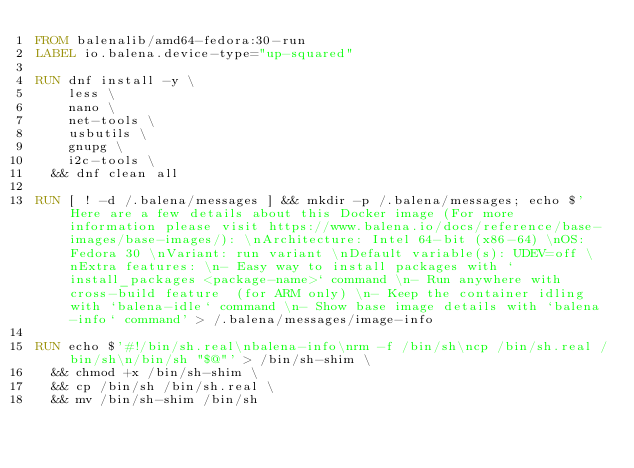<code> <loc_0><loc_0><loc_500><loc_500><_Dockerfile_>FROM balenalib/amd64-fedora:30-run
LABEL io.balena.device-type="up-squared"

RUN dnf install -y \
		less \
		nano \
		net-tools \
		usbutils \
		gnupg \
		i2c-tools \
	&& dnf clean all

RUN [ ! -d /.balena/messages ] && mkdir -p /.balena/messages; echo $'Here are a few details about this Docker image (For more information please visit https://www.balena.io/docs/reference/base-images/base-images/): \nArchitecture: Intel 64-bit (x86-64) \nOS: Fedora 30 \nVariant: run variant \nDefault variable(s): UDEV=off \nExtra features: \n- Easy way to install packages with `install_packages <package-name>` command \n- Run anywhere with cross-build feature  (for ARM only) \n- Keep the container idling with `balena-idle` command \n- Show base image details with `balena-info` command' > /.balena/messages/image-info

RUN echo $'#!/bin/sh.real\nbalena-info\nrm -f /bin/sh\ncp /bin/sh.real /bin/sh\n/bin/sh "$@"' > /bin/sh-shim \
	&& chmod +x /bin/sh-shim \
	&& cp /bin/sh /bin/sh.real \
	&& mv /bin/sh-shim /bin/sh</code> 